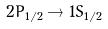<formula> <loc_0><loc_0><loc_500><loc_500>2 P _ { 1 / 2 } \rightarrow 1 S _ { 1 / 2 }</formula> 